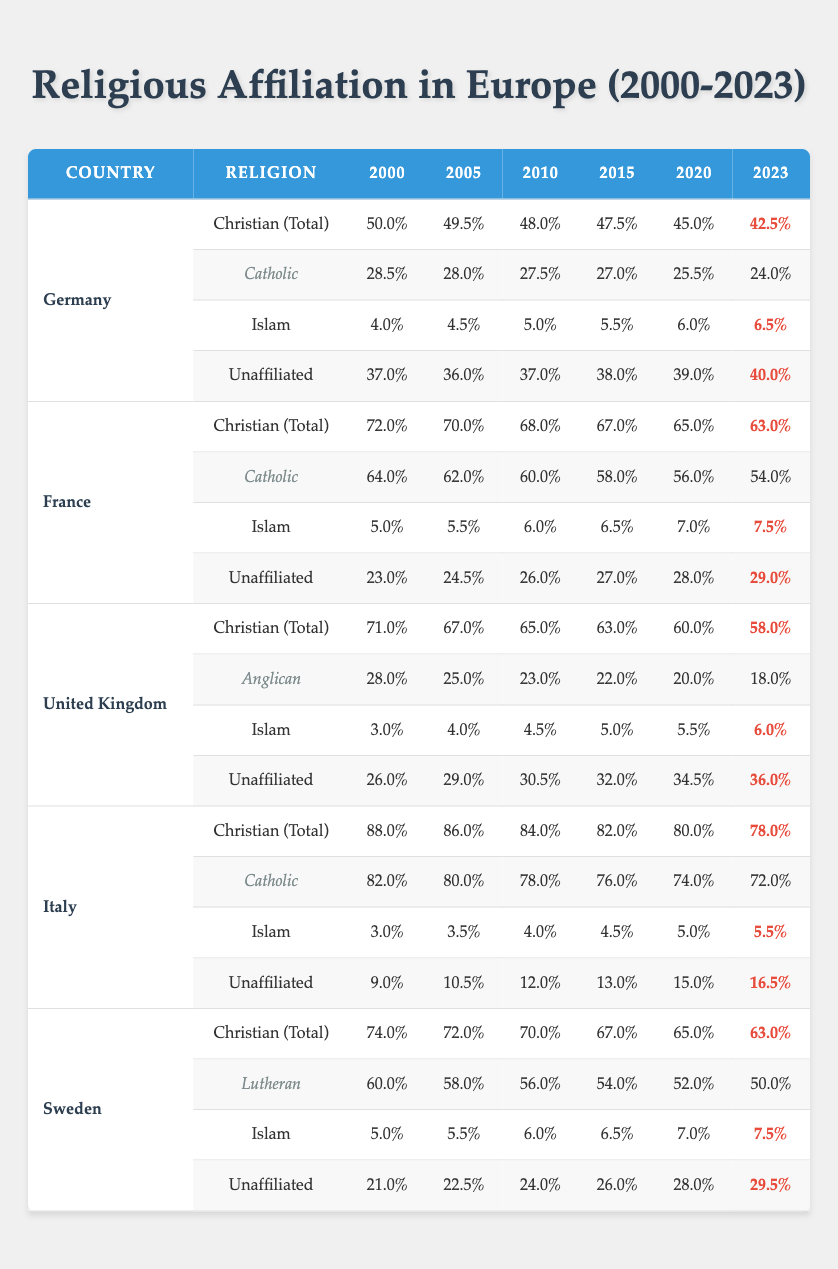What percentage of the population in Germany identified as Unaffiliated in 2023? The table indicates that the percentage of Unaffiliated individuals in Germany for the year 2023 is 40.0%.
Answer: 40.0% How much has the percentage of Christians (Total) in France decreased from 2000 to 2023? From the table, the percentage of Christians (Total) in France was 72.0% in 2000 and decreased to 63.0% in 2023. The difference is 72.0% - 63.0% = 9.0%.
Answer: 9.0% In which country did the Unaffiliated population experience the highest increase between 2000 and 2023? By comparing the Unaffiliated percentages across countries, in Germany it increased from 37.0% to 40.0%, in France from 23.0% to 29.0%, in the United Kingdom from 26.0% to 36.0%, in Italy from 9.0% to 16.5%, and in Sweden from 21.0% to 29.5%. The largest increase is seen in the United Kingdom, with an increase of 10.0%.
Answer: United Kingdom What is the percentage of Muslims in Italy, and has it increased or decreased from 2000 to 2023? For Italy, the percentage of Muslims was 3.0% in 2000 and is now 5.5% in 2023. This indicates an increase of 2.5%.
Answer: Increased Is it true that the overall percentage of Christians in Germany was above 45% in 2015? In the table, the percentage of Christians (Total) in Germany in 2015 was 47.5%. Since 47.5% is greater than 45%, the statement is true.
Answer: Yes What was the average percentage of Unaffiliated individuals in Sweden from 2000 to 2023? The percentages of Unaffiliated individuals in Sweden from 2000 to 2023 are 21.0%, 22.5%, 24.0%, 26.0%, 28.0%, and 29.5%. To find the average, we sum these values: 21.0 + 22.5 + 24.0 + 26.0 + 28.0 + 29.5 = 151.0. There are 6 data points, so the average is 151.0 / 6 = 25.17.
Answer: 25.17 Which country had the highest percentage of Catholic Christians in 2010? By examining the data, in 2010, Germany had 27.5%, France had 60.0%, the United Kingdom had no data for Catholic specifically (only Anglican), Italy had 78.0%, and Sweden had no specific Catholic data. The highest is Italy with 78.0%.
Answer: Italy What was the percentage change of Catholics in Germany from 2000 to 2023? The percentage of Catholic Christians in Germany dropped from 28.5% in 2000 to 24.0% in 2023. The percentage change is (24.0 - 28.5) / 28.5 * 100 = -15.75%.
Answer: -15.75% 